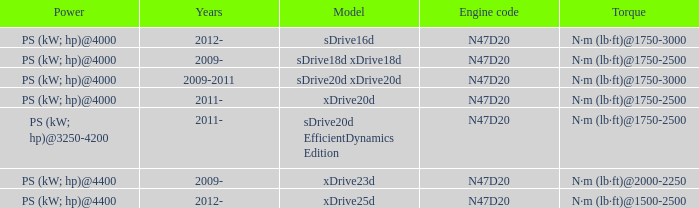What is the torque of the xdrive20d model, which has a power of ps (kw; hp)@4000? N·m (lb·ft)@1750-2500. 